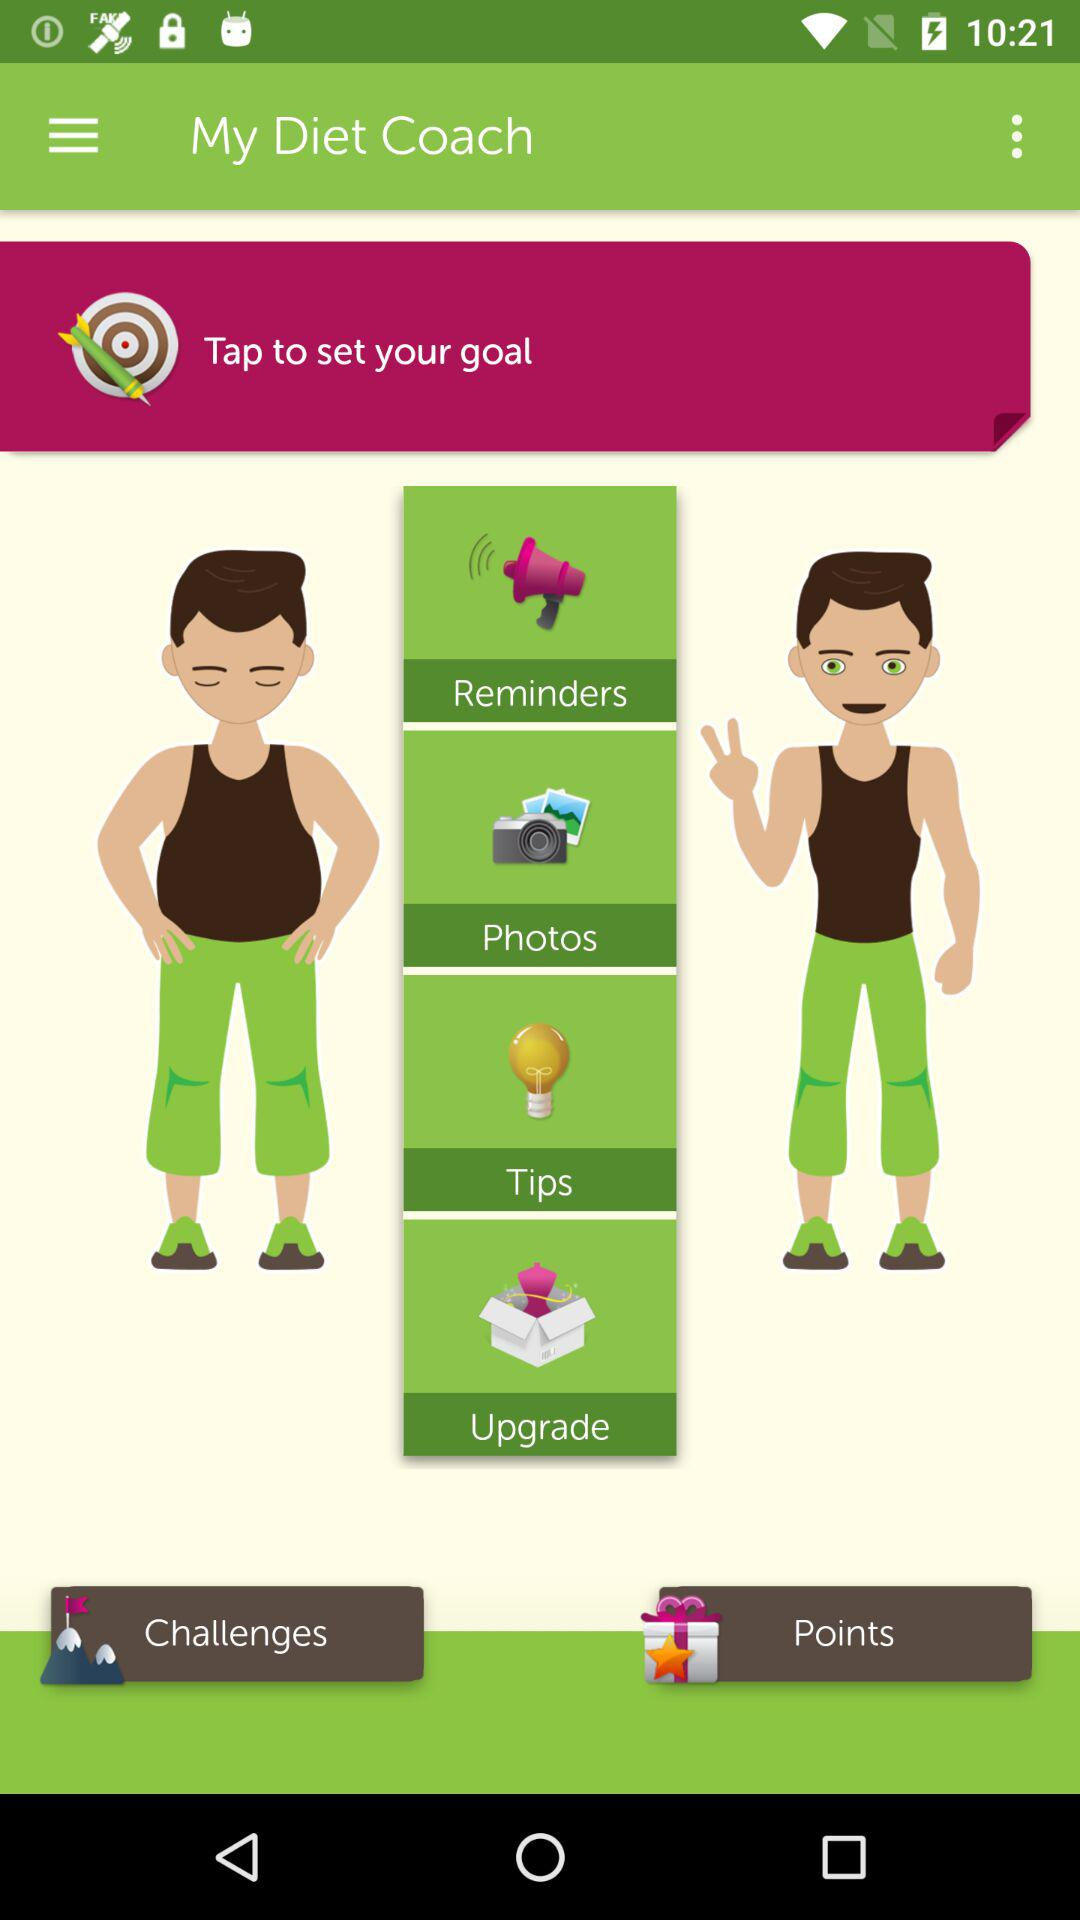What is the application name? The application name is "My Diet Coach". 